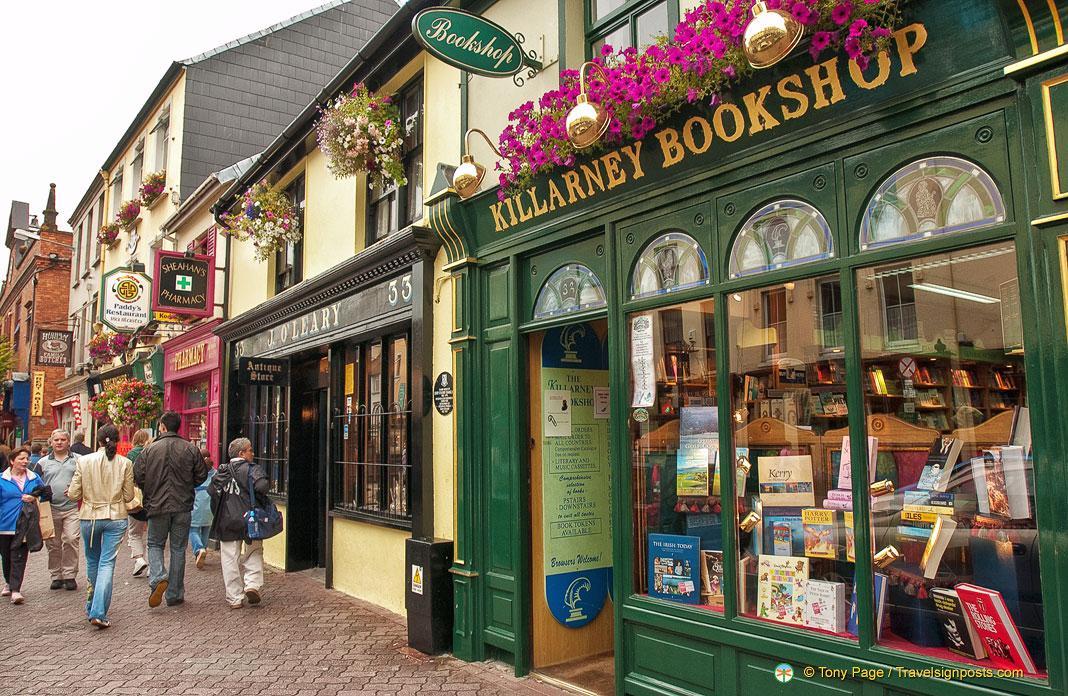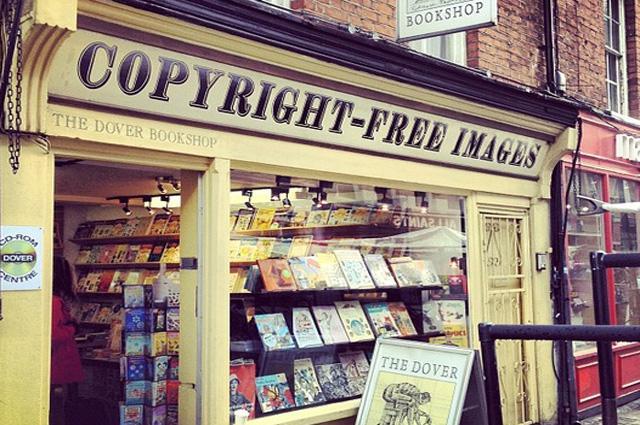The first image is the image on the left, the second image is the image on the right. Assess this claim about the two images: "The bookstore sign has white lettering on a green background.". Correct or not? Answer yes or no. No. The first image is the image on the left, the second image is the image on the right. Considering the images on both sides, is "A bookstore exterior has the store name on an awning over a double door and has a display stand of books outside the doors." valid? Answer yes or no. No. 